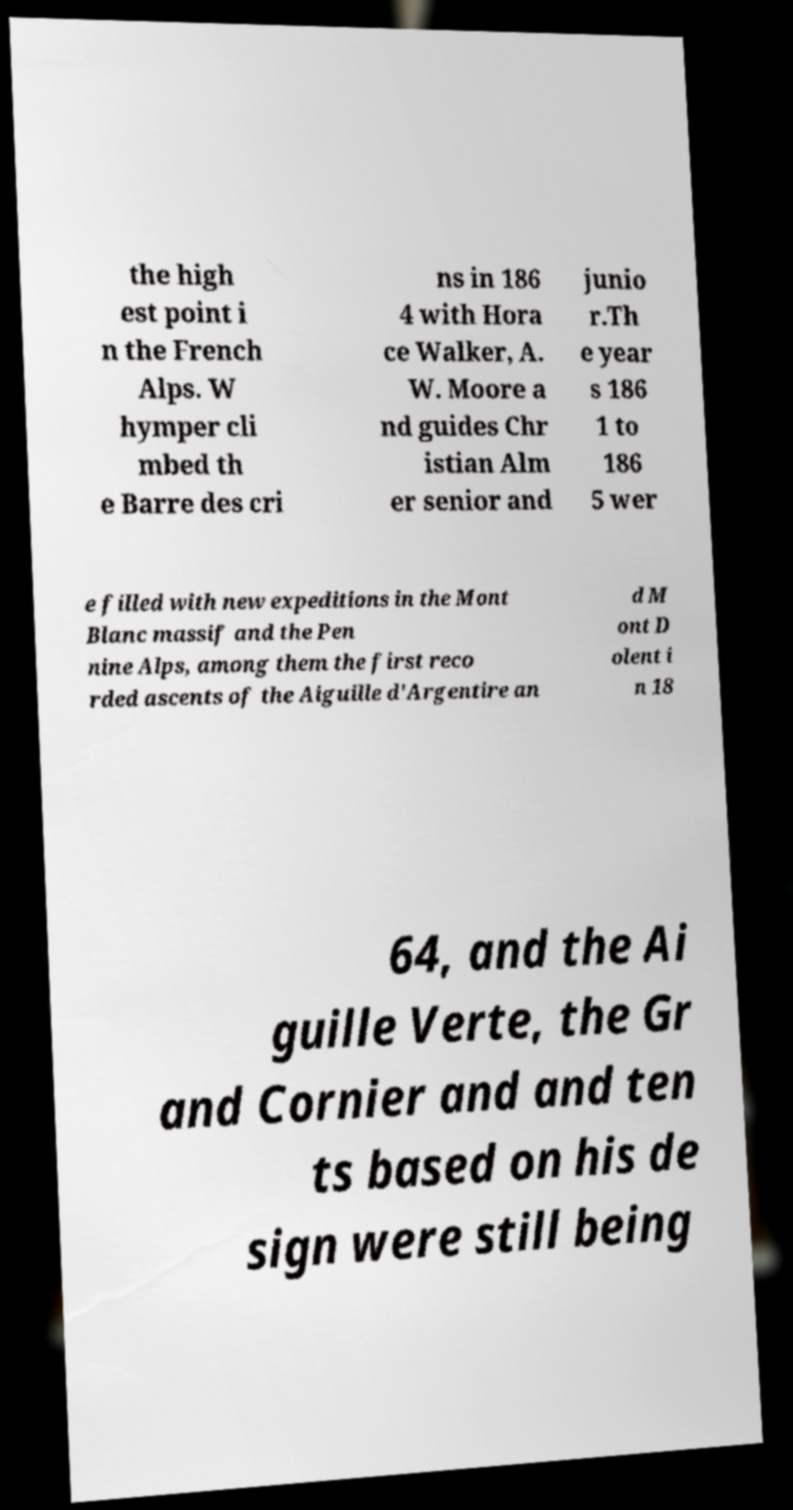There's text embedded in this image that I need extracted. Can you transcribe it verbatim? the high est point i n the French Alps. W hymper cli mbed th e Barre des cri ns in 186 4 with Hora ce Walker, A. W. Moore a nd guides Chr istian Alm er senior and junio r.Th e year s 186 1 to 186 5 wer e filled with new expeditions in the Mont Blanc massif and the Pen nine Alps, among them the first reco rded ascents of the Aiguille d'Argentire an d M ont D olent i n 18 64, and the Ai guille Verte, the Gr and Cornier and and ten ts based on his de sign were still being 